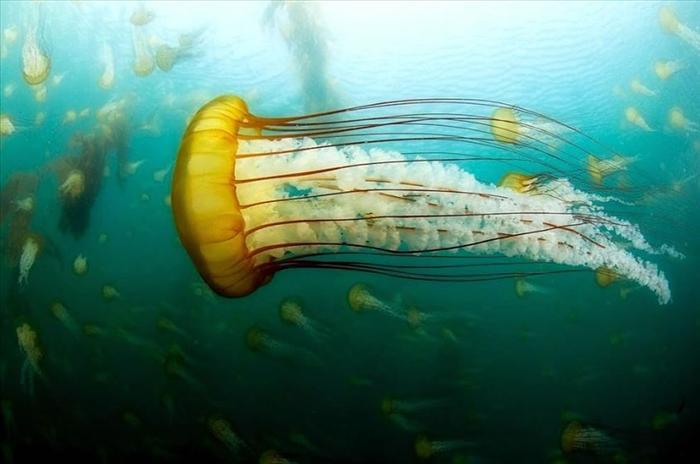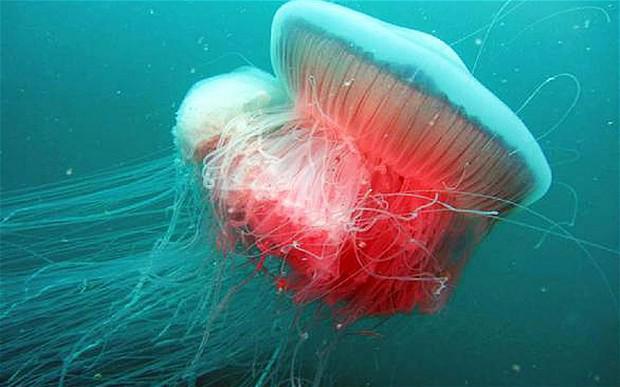The first image is the image on the left, the second image is the image on the right. Examine the images to the left and right. Is the description "There is at least one human visible." accurate? Answer yes or no. No. The first image is the image on the left, the second image is the image on the right. Examine the images to the left and right. Is the description "One jellyfish has pink hues." accurate? Answer yes or no. Yes. 